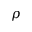Convert formula to latex. <formula><loc_0><loc_0><loc_500><loc_500>\rho</formula> 